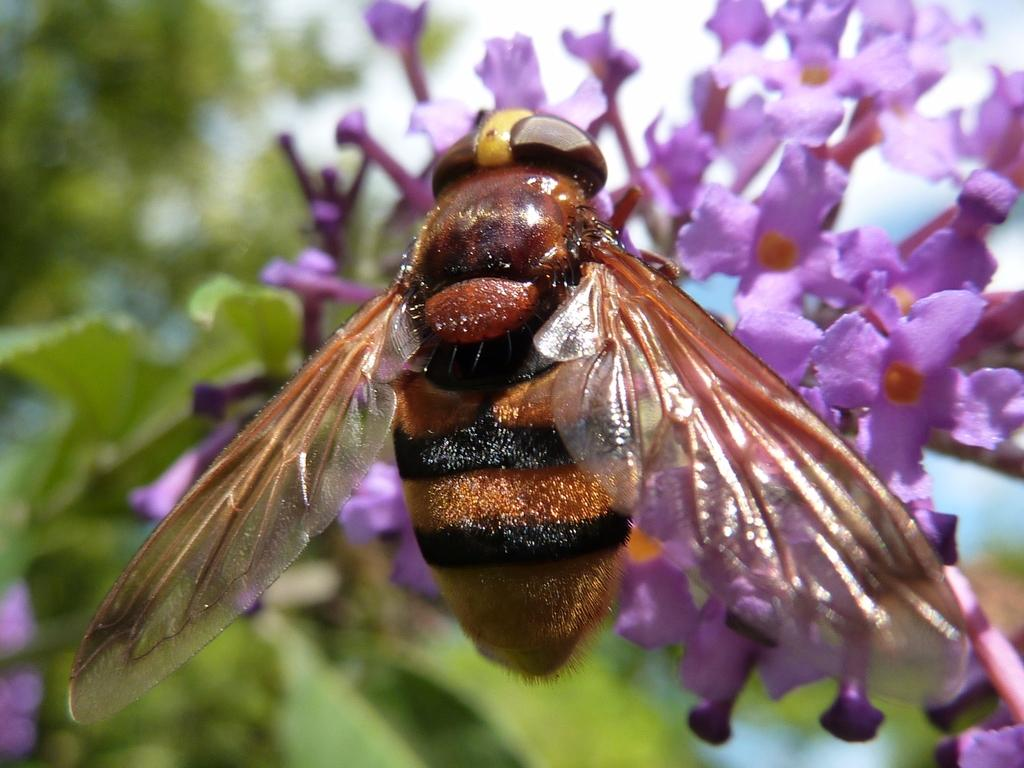What type of living organisms can be seen in the image? There are flowers and an insect in the image. Can you describe the insect's position in relation to the flowers? The insect is on the flowers in the image. What is the background of the image like? The background of the image is blurry. What religious beliefs does the insect in the image follow? There is no indication in the image that the insect has any religious beliefs. What achievements has the insect accomplished in the image? The image does not depict any achievements by the insect; it simply shows the insect on the flowers. 